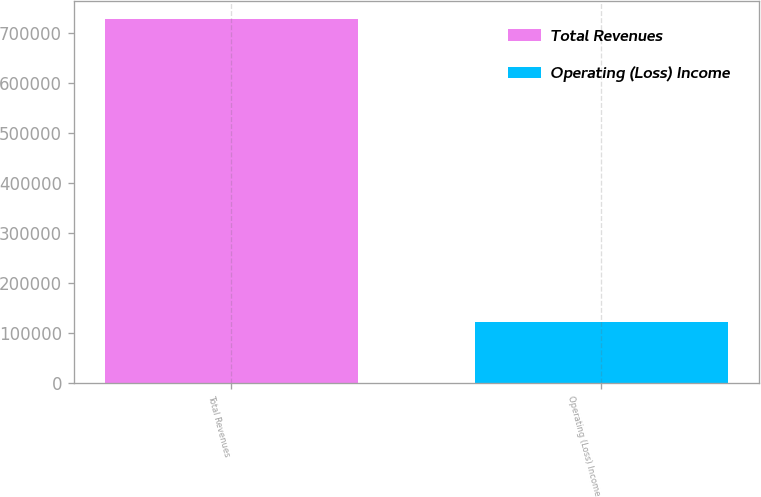<chart> <loc_0><loc_0><loc_500><loc_500><bar_chart><fcel>Total Revenues<fcel>Operating (Loss) Income<nl><fcel>728884<fcel>122559<nl></chart> 